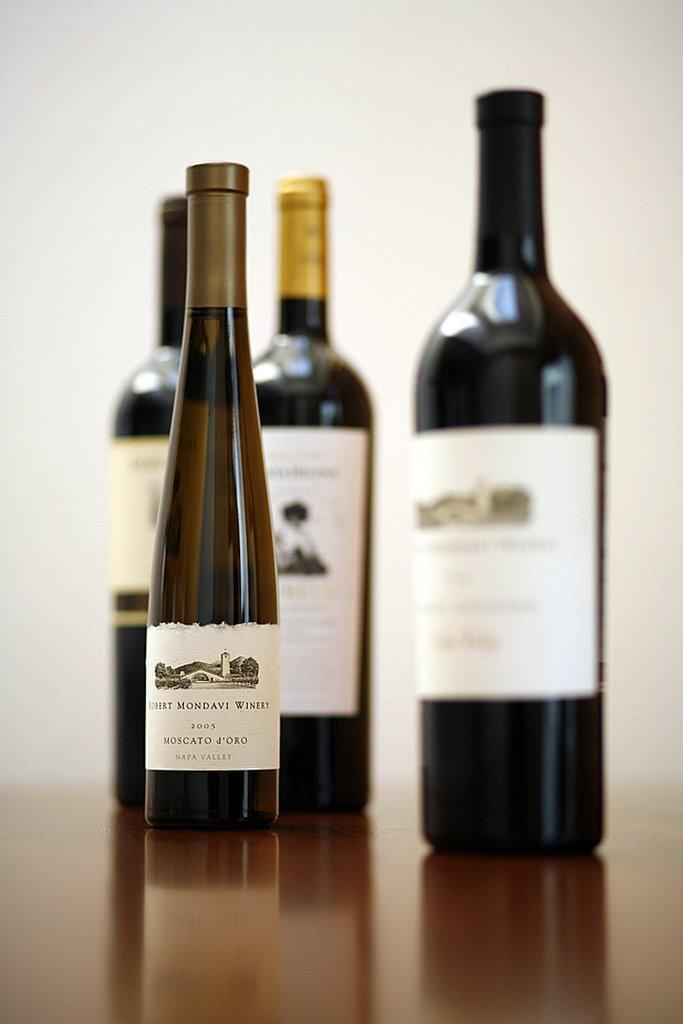<image>
Relay a brief, clear account of the picture shown. A small thin 2003 bottle of wine stands in front of other wine bottles. 